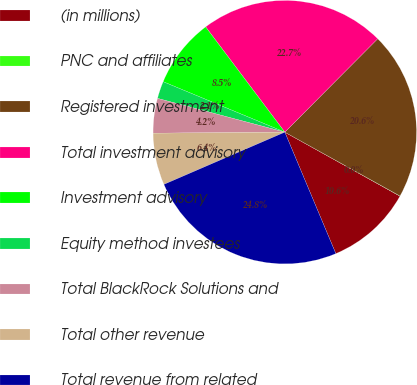Convert chart. <chart><loc_0><loc_0><loc_500><loc_500><pie_chart><fcel>(in millions)<fcel>PNC and affiliates<fcel>Registered investment<fcel>Total investment advisory<fcel>Investment advisory<fcel>Equity method investees<fcel>Total BlackRock Solutions and<fcel>Total other revenue<fcel>Total revenue from related<nl><fcel>10.6%<fcel>0.02%<fcel>20.6%<fcel>22.72%<fcel>8.48%<fcel>2.13%<fcel>4.25%<fcel>6.37%<fcel>24.84%<nl></chart> 